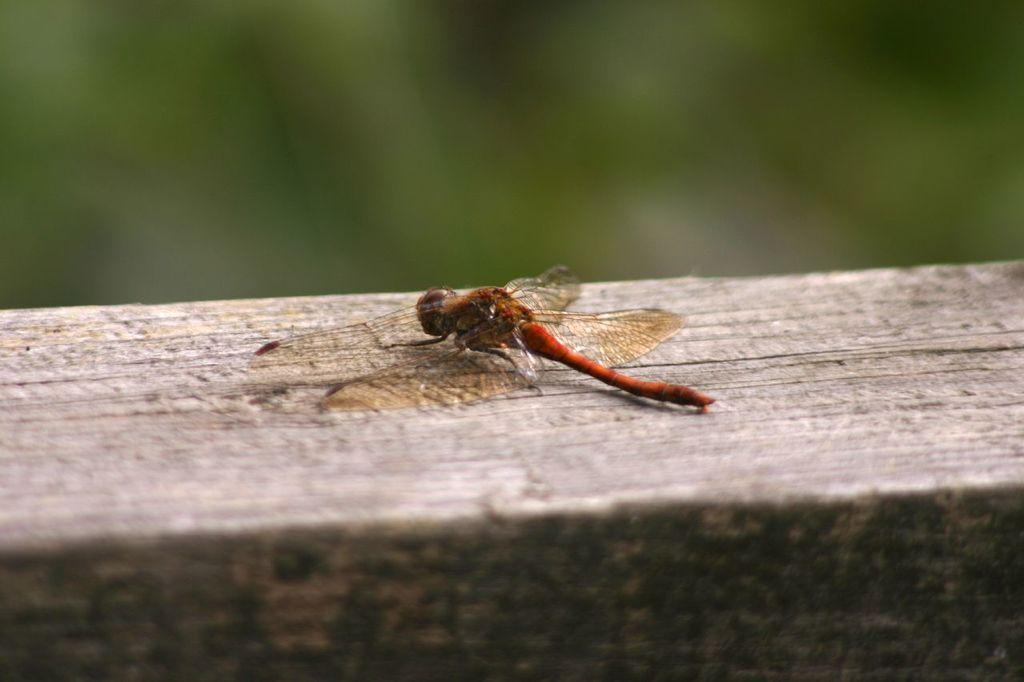What insect is present in the image? There is a dragonfly in the image. What type of surface is the dragonfly resting on? The dragonfly is on a wooden surface. Can you describe the background of the image? The background of the image is blurred. How many bears can be seen jumping in the background of the image? There are no bears or jumping activities present in the image; it features a dragonfly on a wooden surface with a blurred background. 